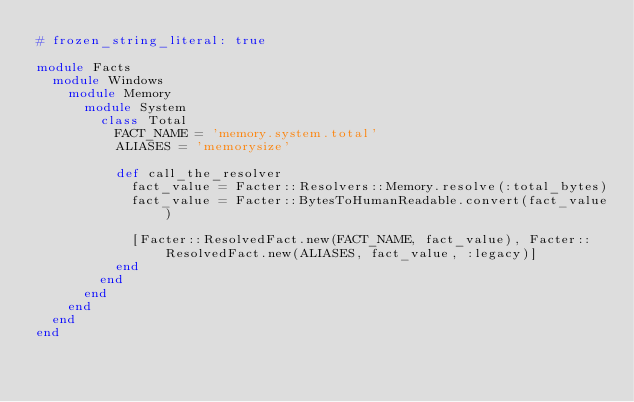<code> <loc_0><loc_0><loc_500><loc_500><_Ruby_># frozen_string_literal: true

module Facts
  module Windows
    module Memory
      module System
        class Total
          FACT_NAME = 'memory.system.total'
          ALIASES = 'memorysize'

          def call_the_resolver
            fact_value = Facter::Resolvers::Memory.resolve(:total_bytes)
            fact_value = Facter::BytesToHumanReadable.convert(fact_value)

            [Facter::ResolvedFact.new(FACT_NAME, fact_value), Facter::ResolvedFact.new(ALIASES, fact_value, :legacy)]
          end
        end
      end
    end
  end
end
</code> 